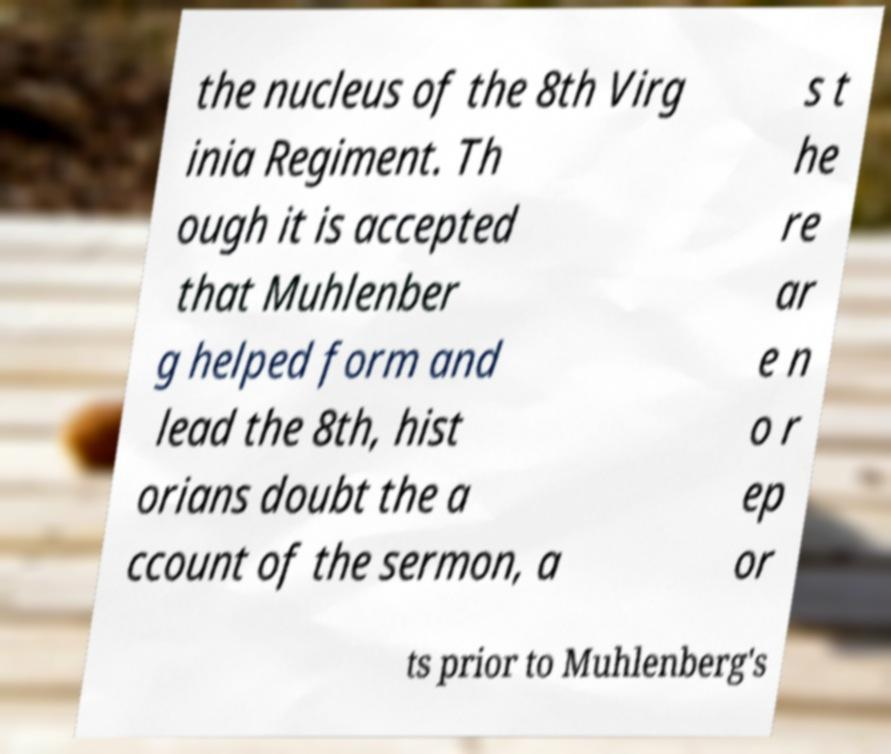Could you extract and type out the text from this image? the nucleus of the 8th Virg inia Regiment. Th ough it is accepted that Muhlenber g helped form and lead the 8th, hist orians doubt the a ccount of the sermon, a s t he re ar e n o r ep or ts prior to Muhlenberg's 